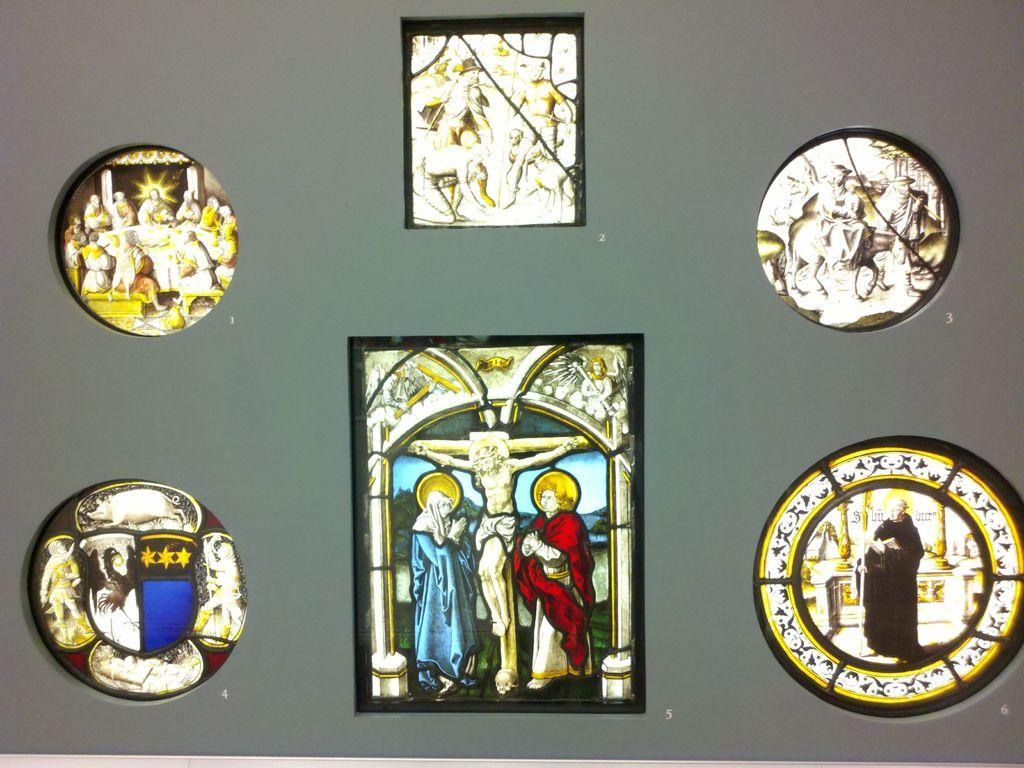What is present on the wall in the image? There is a wall in the image, and it has many photo frames. What can be found inside the photo frames? The photo frames contain paintings. What type of approval is required for the paintings in the image? There is no indication in the image that any approval is required for the paintings. 